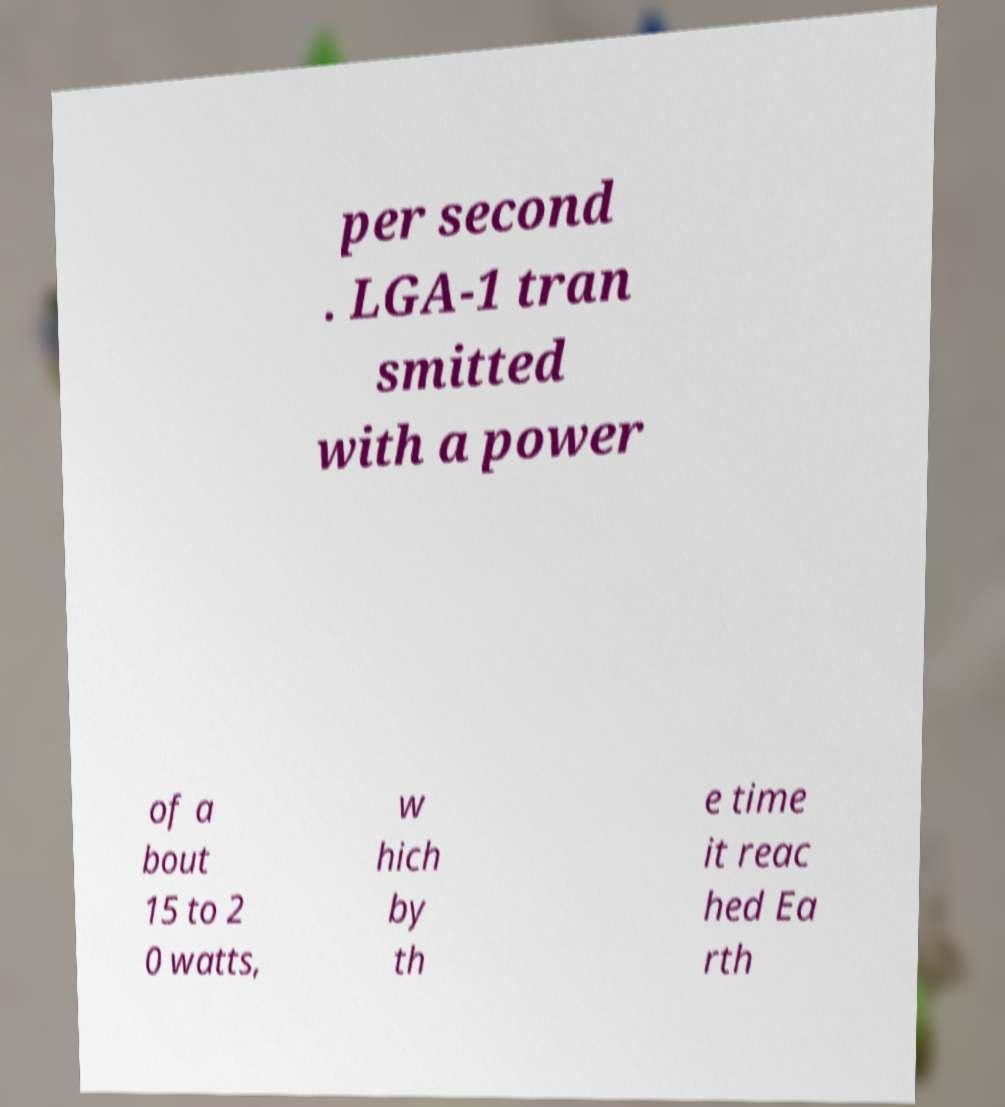Can you read and provide the text displayed in the image?This photo seems to have some interesting text. Can you extract and type it out for me? per second . LGA-1 tran smitted with a power of a bout 15 to 2 0 watts, w hich by th e time it reac hed Ea rth 